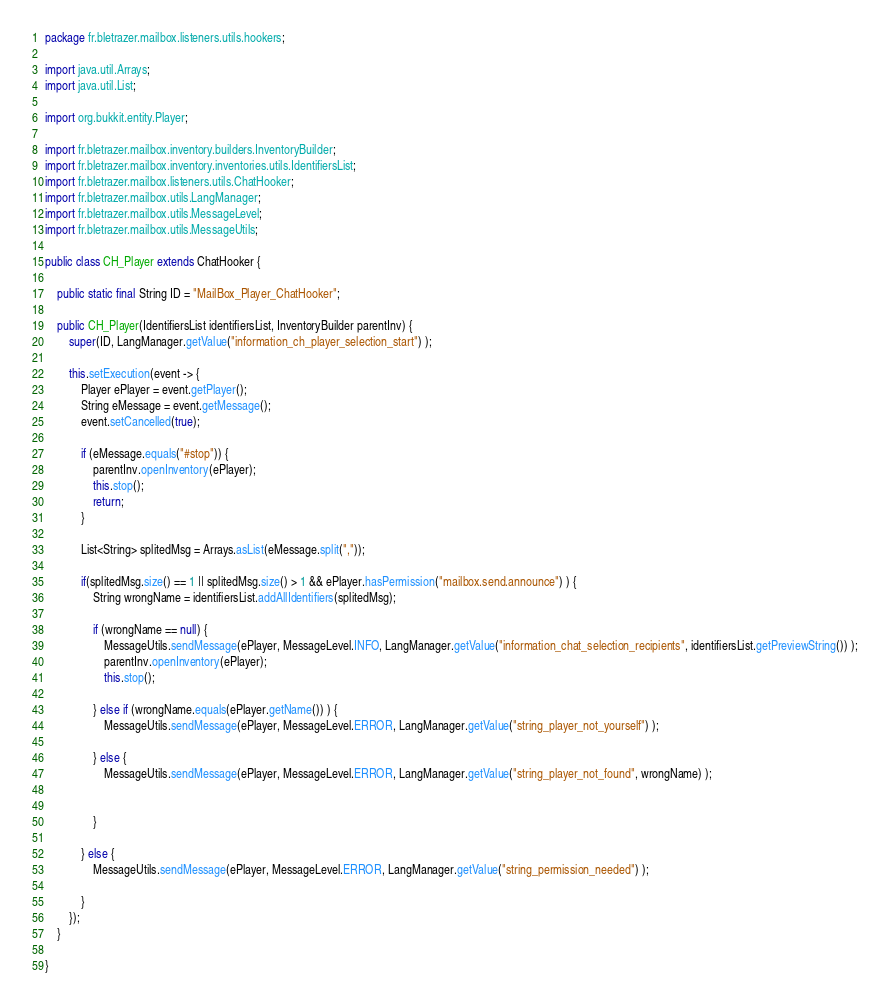<code> <loc_0><loc_0><loc_500><loc_500><_Java_>package fr.bletrazer.mailbox.listeners.utils.hookers;

import java.util.Arrays;
import java.util.List;

import org.bukkit.entity.Player;

import fr.bletrazer.mailbox.inventory.builders.InventoryBuilder;
import fr.bletrazer.mailbox.inventory.inventories.utils.IdentifiersList;
import fr.bletrazer.mailbox.listeners.utils.ChatHooker;
import fr.bletrazer.mailbox.utils.LangManager;
import fr.bletrazer.mailbox.utils.MessageLevel;
import fr.bletrazer.mailbox.utils.MessageUtils;

public class CH_Player extends ChatHooker {
	
	public static final String ID = "MailBox_Player_ChatHooker";
	
	public CH_Player(IdentifiersList identifiersList, InventoryBuilder parentInv) {
		super(ID, LangManager.getValue("information_ch_player_selection_start") );

		this.setExecution(event -> {
			Player ePlayer = event.getPlayer();
			String eMessage = event.getMessage();
			event.setCancelled(true);

			if (eMessage.equals("#stop")) {
				parentInv.openInventory(ePlayer);
				this.stop();
				return;
			}

			List<String> splitedMsg = Arrays.asList(eMessage.split(","));
			
			if(splitedMsg.size() == 1 || splitedMsg.size() > 1 && ePlayer.hasPermission("mailbox.send.announce") ) {
				String wrongName = identifiersList.addAllIdentifiers(splitedMsg);
	
				if (wrongName == null) {
					MessageUtils.sendMessage(ePlayer, MessageLevel.INFO, LangManager.getValue("information_chat_selection_recipients", identifiersList.getPreviewString()) );
					parentInv.openInventory(ePlayer);
					this.stop();
	
				} else if (wrongName.equals(ePlayer.getName()) ) {
					MessageUtils.sendMessage(ePlayer, MessageLevel.ERROR, LangManager.getValue("string_player_not_yourself") );
					
				} else {
					MessageUtils.sendMessage(ePlayer, MessageLevel.ERROR, LangManager.getValue("string_player_not_found", wrongName) );
					
	
				}
				
			} else {
				MessageUtils.sendMessage(ePlayer, MessageLevel.ERROR, LangManager.getValue("string_permission_needed") );
				
			}
		});
	}

}
</code> 